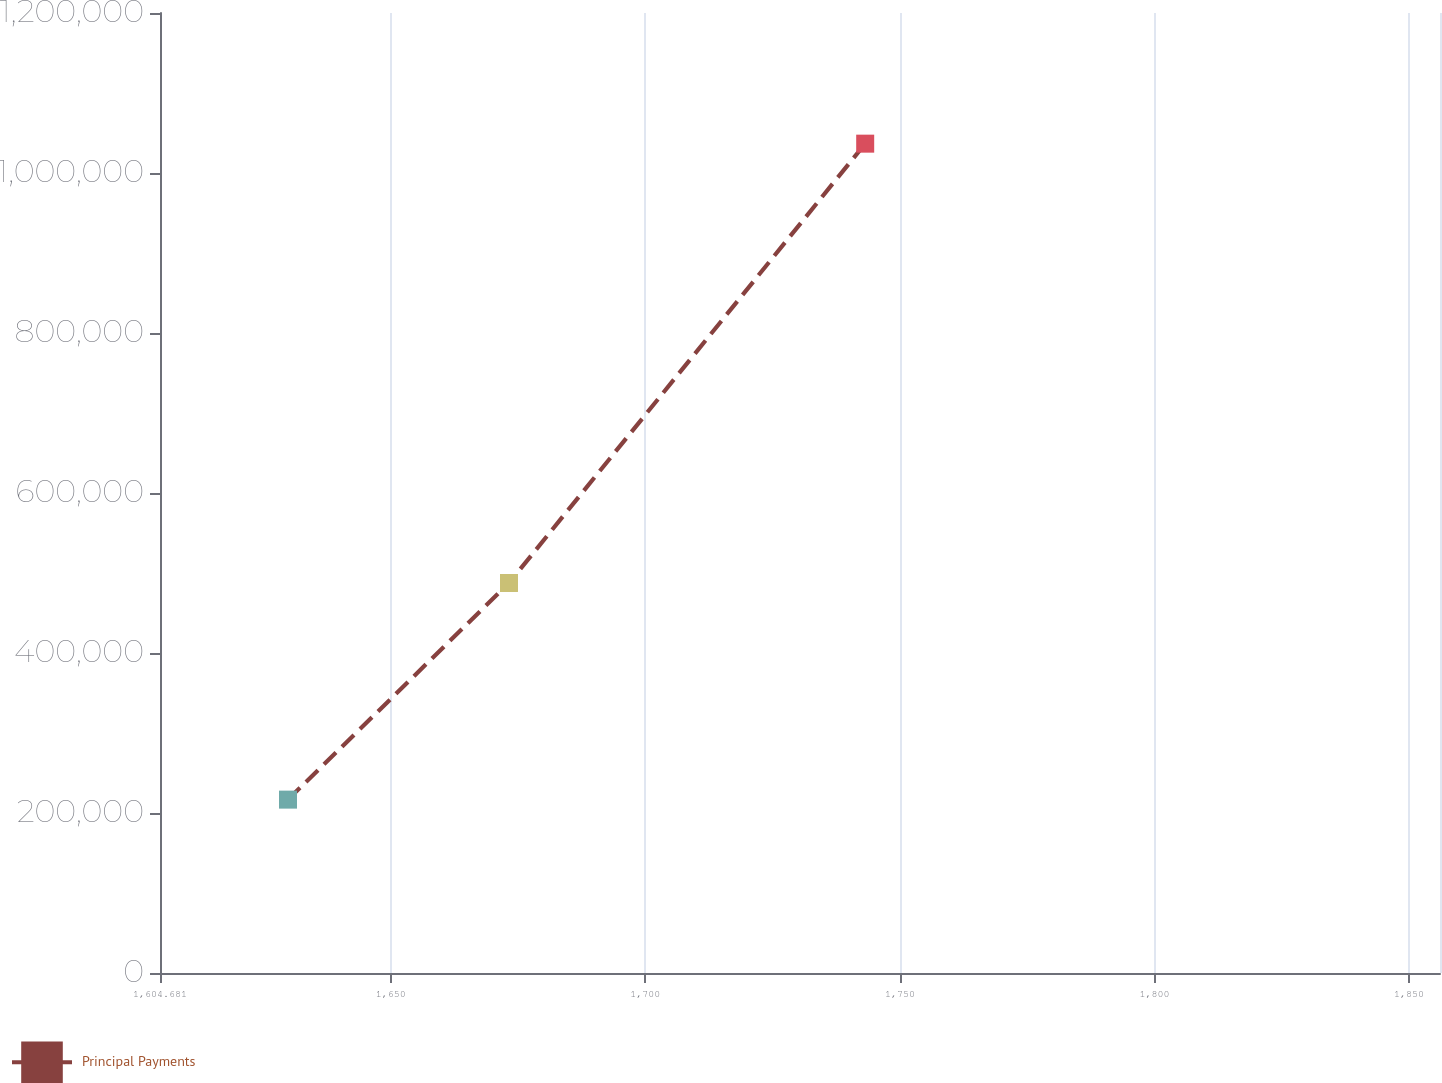Convert chart to OTSL. <chart><loc_0><loc_0><loc_500><loc_500><line_chart><ecel><fcel>Principal Payments<nl><fcel>1629.82<fcel>216722<nl><fcel>1673.22<fcel>487522<nl><fcel>1743.18<fcel>1.03667e+06<nl><fcel>1857.37<fcel>307828<nl><fcel>1881.21<fcel>125617<nl></chart> 